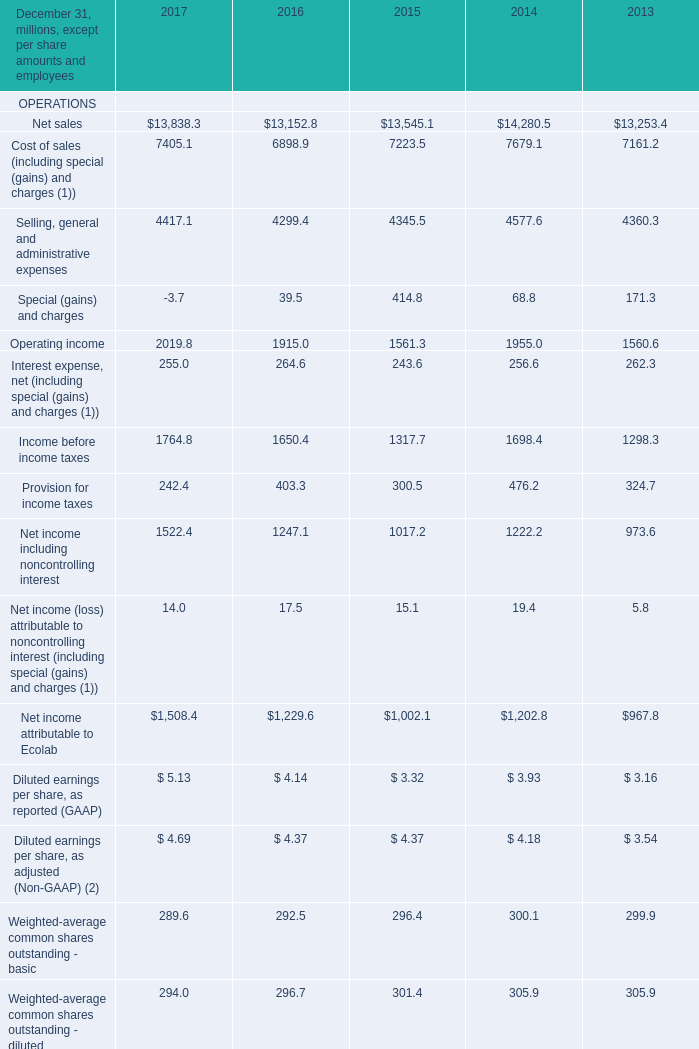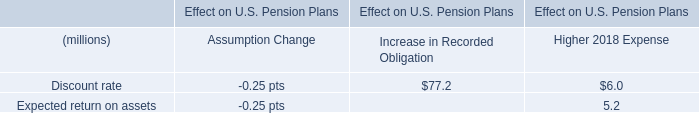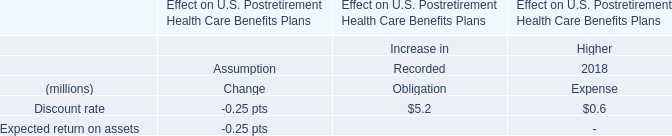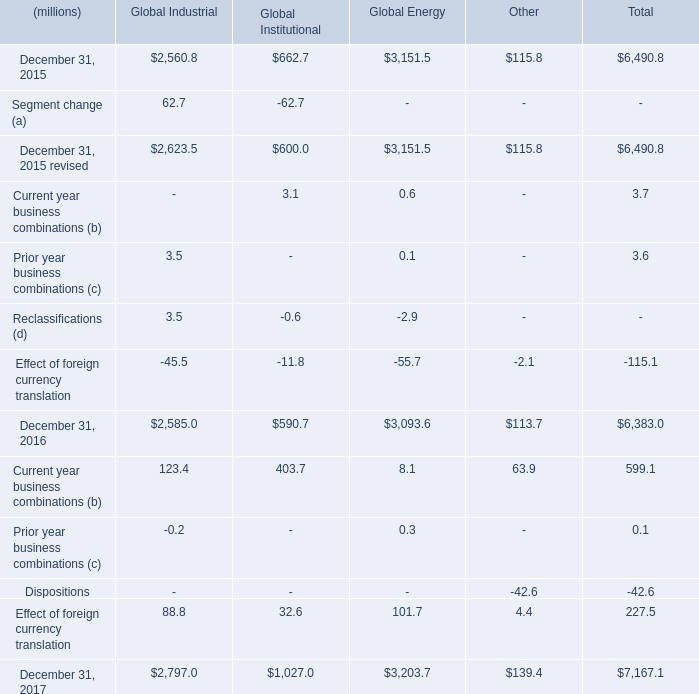what is the percentage change in the total carrying amount of goodwill from 2016 to 2017? 
Computations: ((7167.1 - 6383.0) / 6383.0)
Answer: 0.12284. 